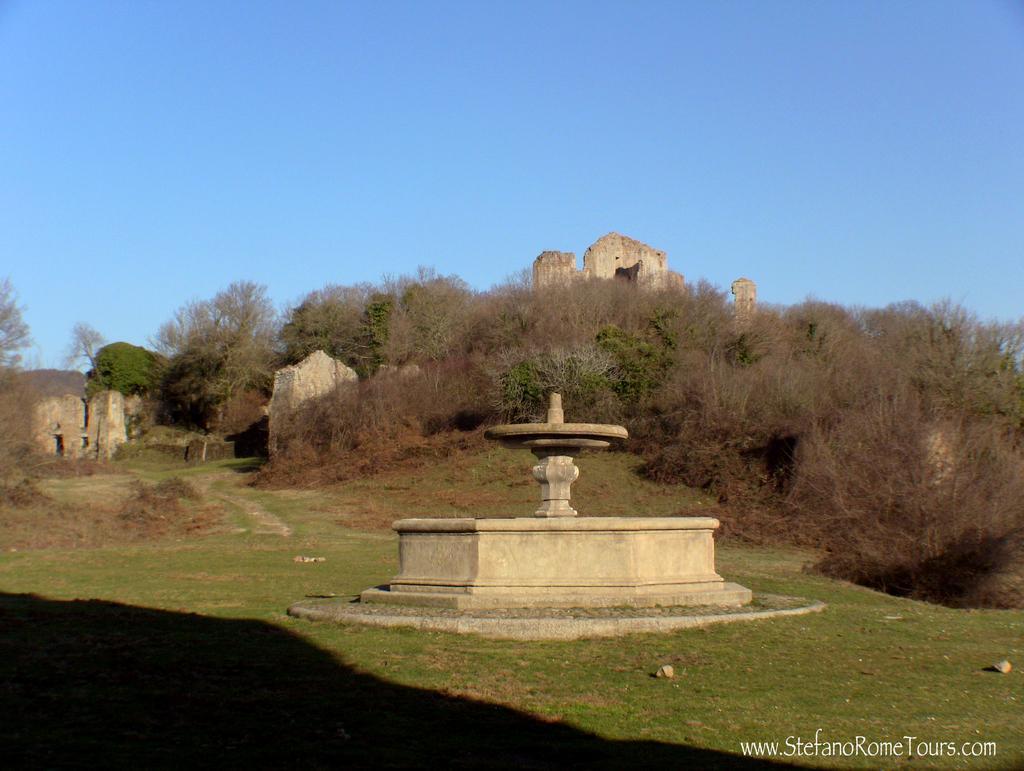Please provide a concise description of this image. In this image there is a fountain, in the background there are plants and monuments and the sky. 